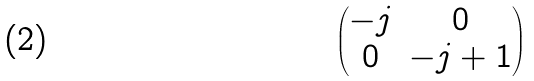<formula> <loc_0><loc_0><loc_500><loc_500>\begin{pmatrix} - j & 0 \\ 0 & - j + 1 \end{pmatrix}</formula> 